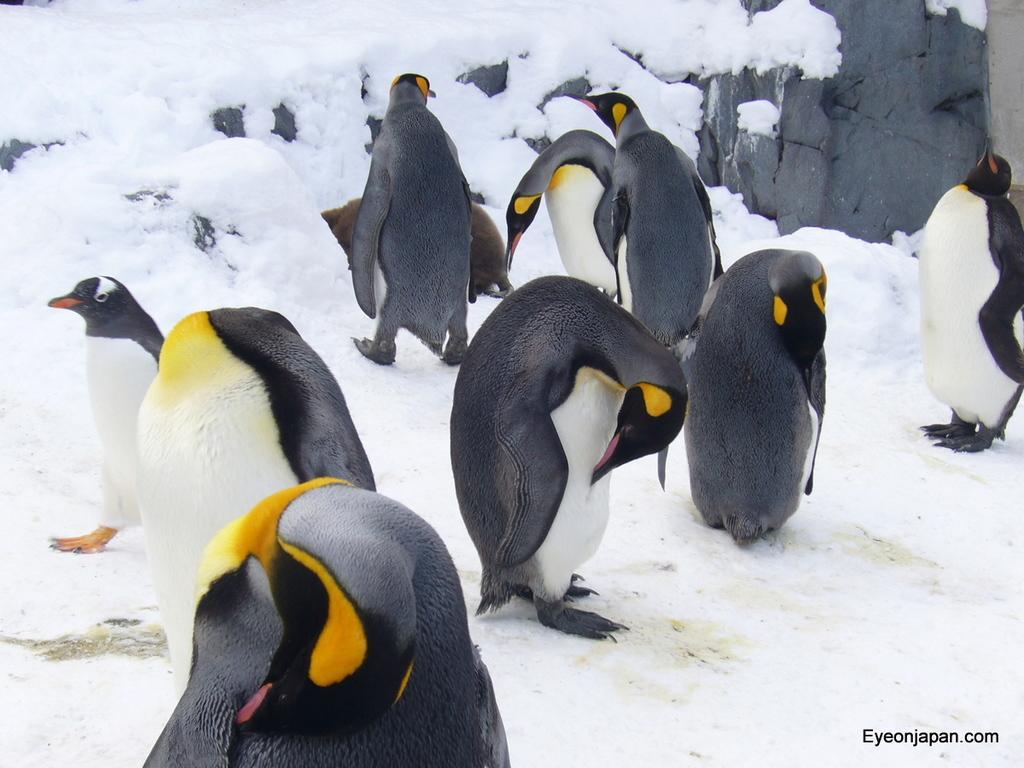Can you describe this image briefly? In the center of the image there are penguins. At the bottom there is snow. On the right we can see a rock. 